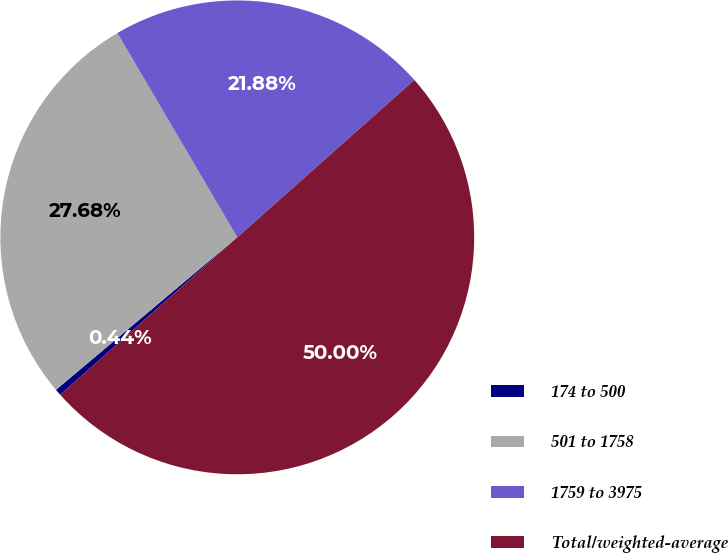Convert chart. <chart><loc_0><loc_0><loc_500><loc_500><pie_chart><fcel>174 to 500<fcel>501 to 1758<fcel>1759 to 3975<fcel>Total/weighted-average<nl><fcel>0.44%<fcel>27.68%<fcel>21.88%<fcel>50.0%<nl></chart> 